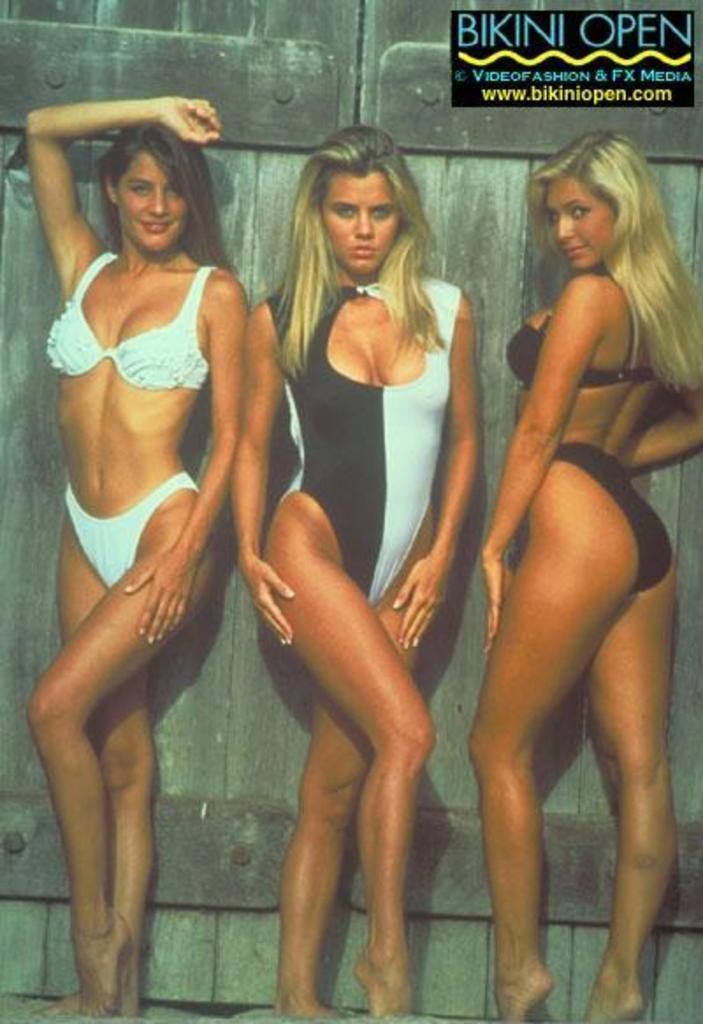Can you describe this image briefly? In this image, we can see three women are standing. In the background, we can see a wood door. 